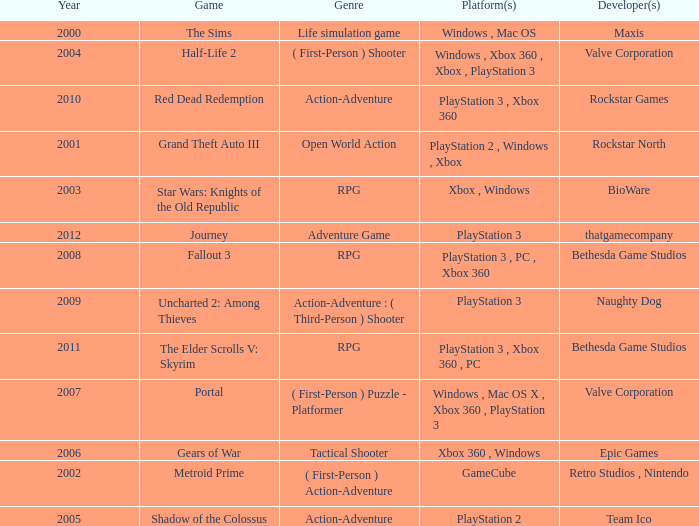What game was in 2005? Shadow of the Colossus. Could you parse the entire table as a dict? {'header': ['Year', 'Game', 'Genre', 'Platform(s)', 'Developer(s)'], 'rows': [['2000', 'The Sims', 'Life simulation game', 'Windows , Mac OS', 'Maxis'], ['2004', 'Half-Life 2', '( First-Person ) Shooter', 'Windows , Xbox 360 , Xbox , PlayStation 3', 'Valve Corporation'], ['2010', 'Red Dead Redemption', 'Action-Adventure', 'PlayStation 3 , Xbox 360', 'Rockstar Games'], ['2001', 'Grand Theft Auto III', 'Open World Action', 'PlayStation 2 , Windows , Xbox', 'Rockstar North'], ['2003', 'Star Wars: Knights of the Old Republic', 'RPG', 'Xbox , Windows', 'BioWare'], ['2012', 'Journey', 'Adventure Game', 'PlayStation 3', 'thatgamecompany'], ['2008', 'Fallout 3', 'RPG', 'PlayStation 3 , PC , Xbox 360', 'Bethesda Game Studios'], ['2009', 'Uncharted 2: Among Thieves', 'Action-Adventure : ( Third-Person ) Shooter', 'PlayStation 3', 'Naughty Dog'], ['2011', 'The Elder Scrolls V: Skyrim', 'RPG', 'PlayStation 3 , Xbox 360 , PC', 'Bethesda Game Studios'], ['2007', 'Portal', '( First-Person ) Puzzle - Platformer', 'Windows , Mac OS X , Xbox 360 , PlayStation 3', 'Valve Corporation'], ['2006', 'Gears of War', 'Tactical Shooter', 'Xbox 360 , Windows', 'Epic Games'], ['2002', 'Metroid Prime', '( First-Person ) Action-Adventure', 'GameCube', 'Retro Studios , Nintendo'], ['2005', 'Shadow of the Colossus', 'Action-Adventure', 'PlayStation 2', 'Team Ico']]} 